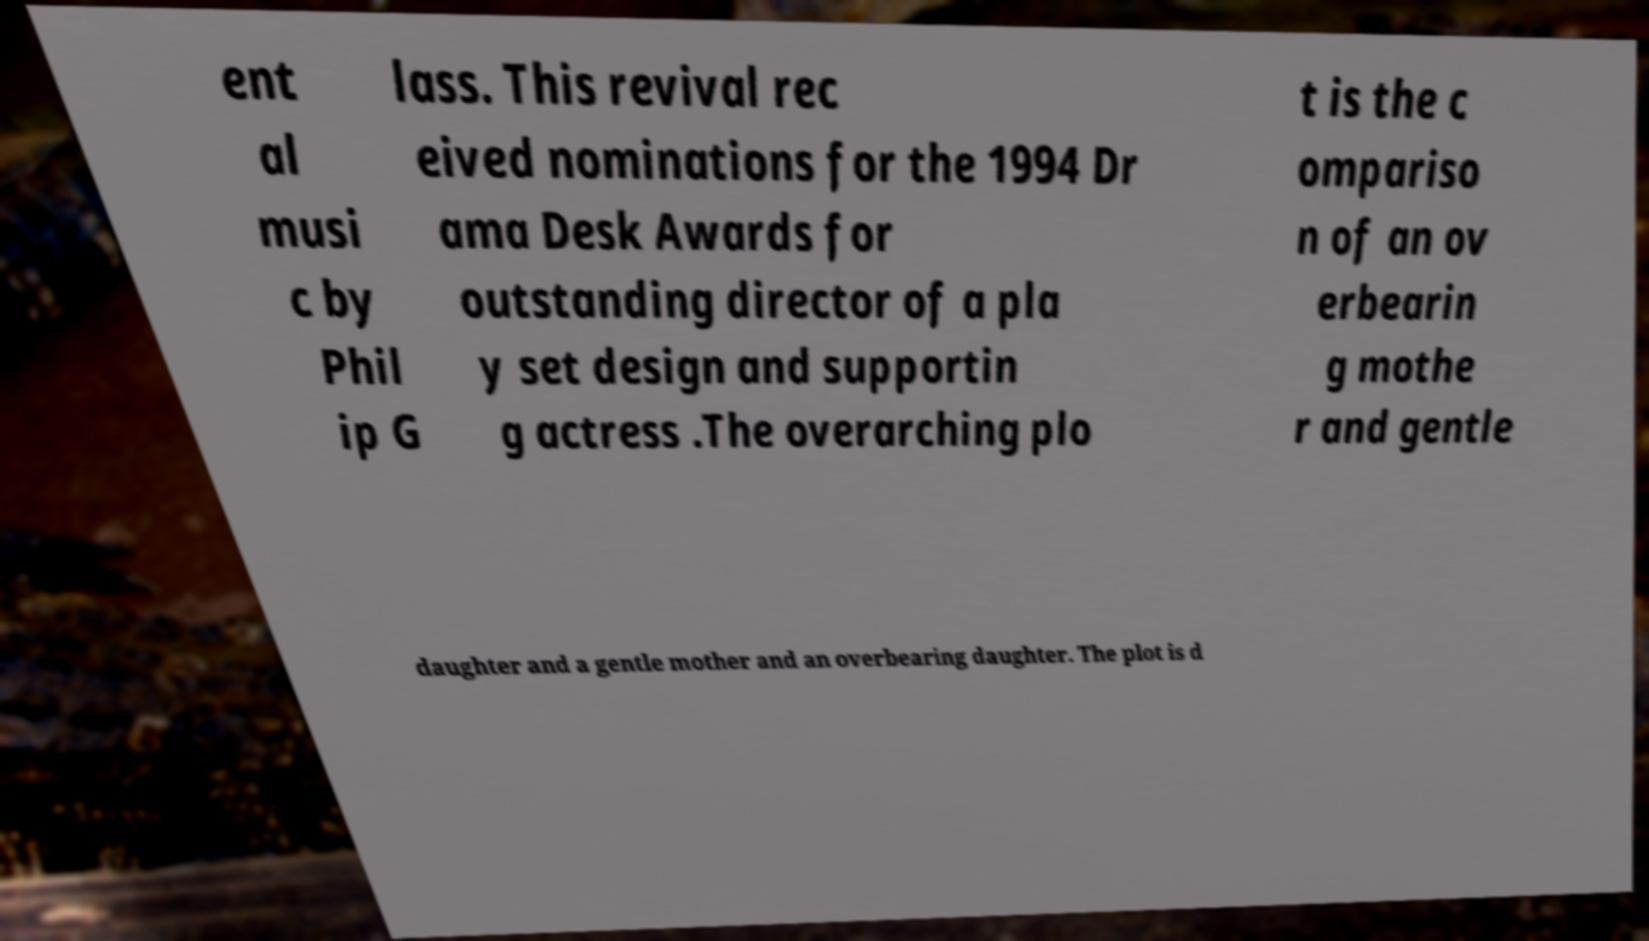Can you accurately transcribe the text from the provided image for me? ent al musi c by Phil ip G lass. This revival rec eived nominations for the 1994 Dr ama Desk Awards for outstanding director of a pla y set design and supportin g actress .The overarching plo t is the c ompariso n of an ov erbearin g mothe r and gentle daughter and a gentle mother and an overbearing daughter. The plot is d 